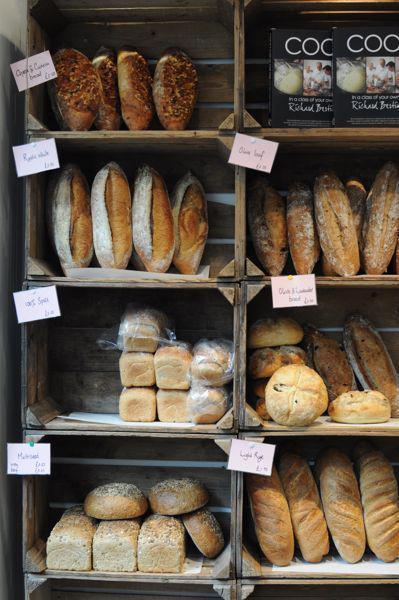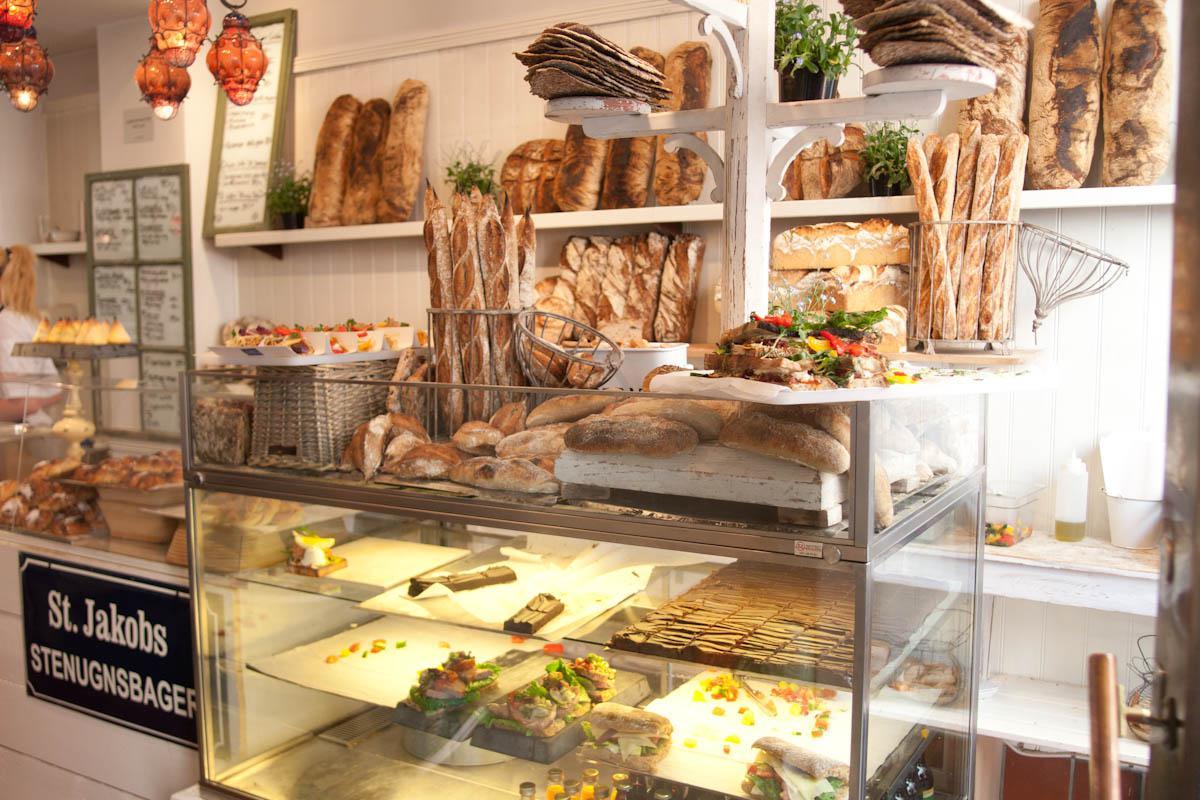The first image is the image on the left, the second image is the image on the right. Analyze the images presented: Is the assertion "The left image shows tiered shelves of baked goods behind glass, with white cards above some items facing the glass." valid? Answer yes or no. No. The first image is the image on the left, the second image is the image on the right. Assess this claim about the two images: "Two bakery windows show the reflection of at least one person.". Correct or not? Answer yes or no. No. 